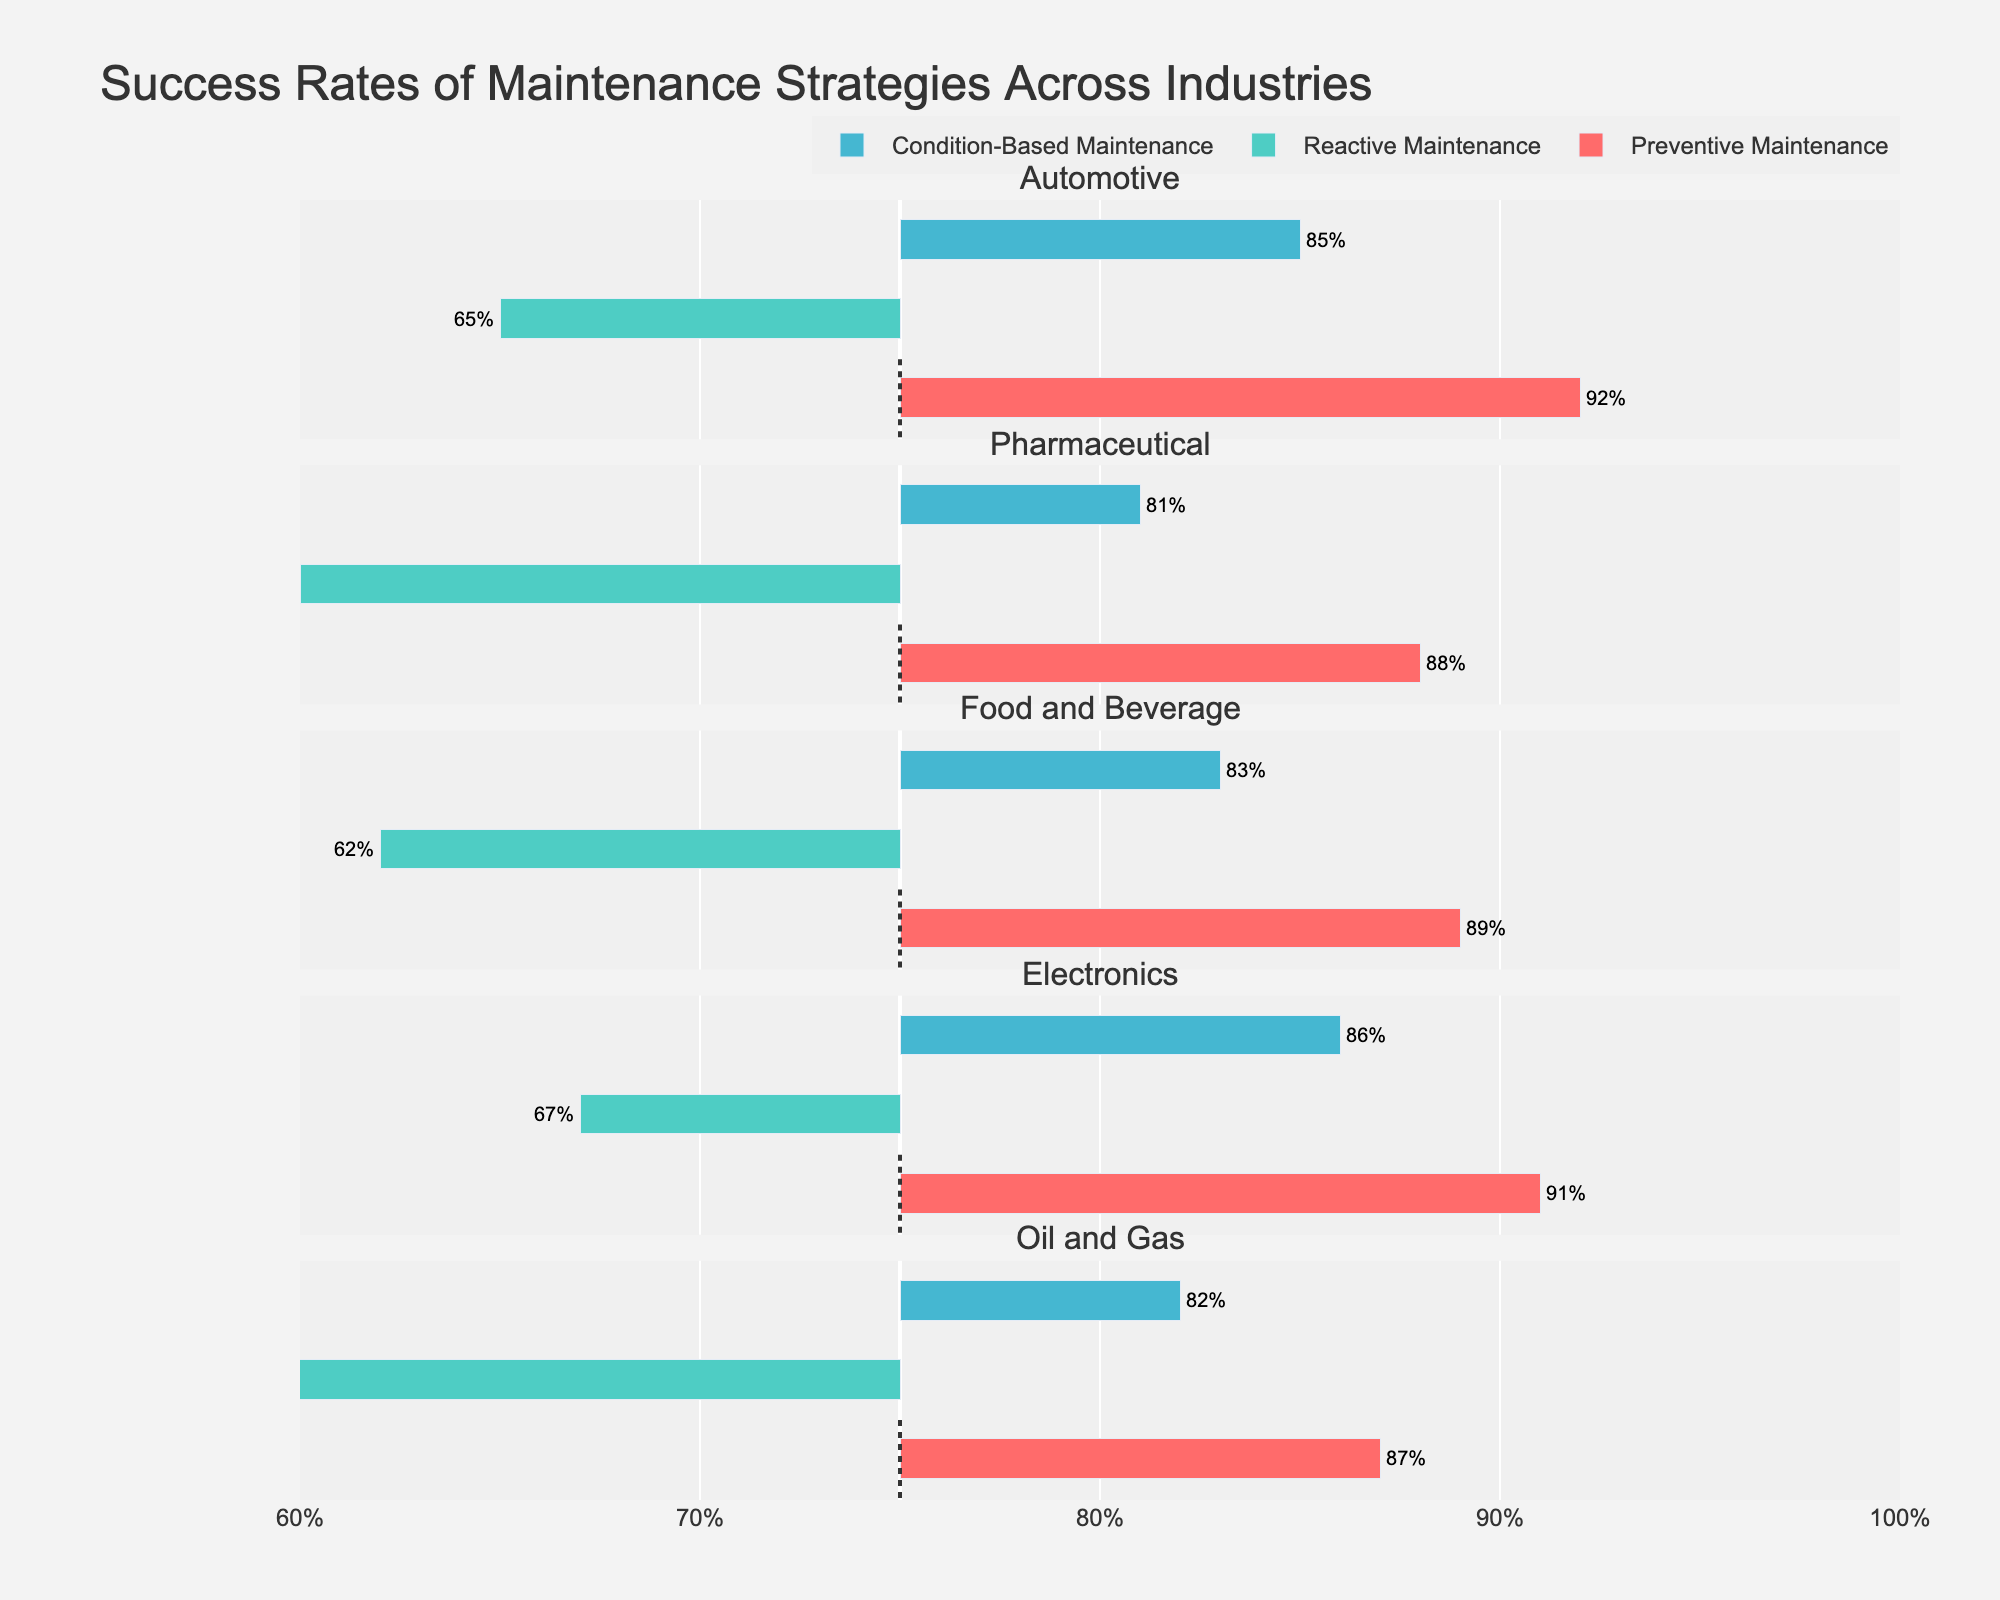What is the success rate of Preventive Maintenance in the Automotive industry? The success rate of Preventive Maintenance in the Automotive industry can be directly read from the figure. It is depicted by the length of the bar corresponding to Preventive Maintenance under the Automotive industry.
Answer: 92% Which industry has the lowest success rate for Reactive Maintenance? To determine the industry with the lowest success rate for Reactive Maintenance, compare the lengths of the bars corresponding to Reactive Maintenance across all industries. The shortest bar indicates the lowest success rate.
Answer: Oil and Gas How does the success rate of Condition-Based Maintenance in the Pharmaceutical industry compare to that in the Electronics industry? Look at the bars representing Condition-Based Maintenance in both the Pharmaceutical and Electronics industries. The success rate in the Pharmaceutical industry is 81%, and in the Electronics industry, it is 86%. Hence, Condition-Based Maintenance in the Electronics industry has a higher success rate.
Answer: Higher in Electronics, 86% vs. 81% What is the average success rate of Preventive Maintenance across all industries? Calculate the average by summing the success rates of Preventive Maintenance in each industry and dividing by the number of industries. Preventive Maintenance success rates are: 92, 88, 89, 91, 87. The average is (92 + 88 + 89 + 91 + 87) / 5 = 89.4.
Answer: 89.4% Which maintenance strategy has the most consistent success rate across the industries? To determine consistency, observe the variation in success rates of each strategy across different industries. Preventive Maintenance success rates are closely clustered between 87% and 92%. This small range indicates it is the most consistent.
Answer: Preventive Maintenance By how much does the success rate of Reactive Maintenance in the Automotive industry differ from that in the Electronics industry? Subtract the success rate of Reactive Maintenance in the Electronics industry from that in the Automotive industry. Automotive is 65%, Electronics is 67%. The difference is 67 - 65 = 2%.
Answer: 2% Which industry shows the largest gap between the highest and lowest success rates among the maintenance strategies? Calculate the range (difference between highest and lowest success rate) for each industry. The largest gap is in the Automotive industry: 92% (Preventive) - 65% (Reactive) = 27%.
Answer: Automotive industry, 27% In which industry does Condition-Based Maintenance achieve a success rate closest to 85%? Compare the success rates of Condition-Based Maintenance across industries to identify which is closest to 85%. Automotive's rate is 85%, which is exactly 85%.
Answer: Automotive How many industries have a Preventive Maintenance success rate above 90%? Count the industries where the Preventive Maintenance success rate exceeds 90%. Automotive (92%), Electronics (91%) both exceed 90%.
Answer: 2 industries What is the difference between the highest and lowest success rates of Condition-Based Maintenance? Find the highest and lowest success rates for Condition-Based Maintenance. The highest is 86% (Electronics), the lowest is 81% (Pharmaceutical). The difference is 86 - 81 = 5%.
Answer: 5% 